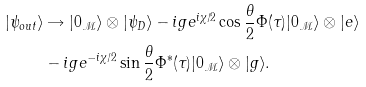<formula> <loc_0><loc_0><loc_500><loc_500>| \psi _ { o u t } \rangle & \rightarrow | 0 _ { \mathcal { M } } \rangle \otimes | \psi _ { D } \rangle - i g e ^ { i \chi / 2 } \cos \frac { \theta } { 2 } \Phi ( \tau ) | 0 _ { \mathcal { M } } \rangle \otimes | e \rangle \\ & - i g e ^ { - i \chi / 2 } \sin \frac { \theta } { 2 } \Phi ^ { * } ( \tau ) | 0 _ { \mathcal { M } } \rangle \otimes | g \rangle .</formula> 